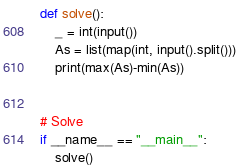Convert code to text. <code><loc_0><loc_0><loc_500><loc_500><_Python_>

def solve():
    _ = int(input())
    As = list(map(int, input().split()))
    print(max(As)-min(As))


# Solve
if __name__ == "__main__":
    solve()
</code> 